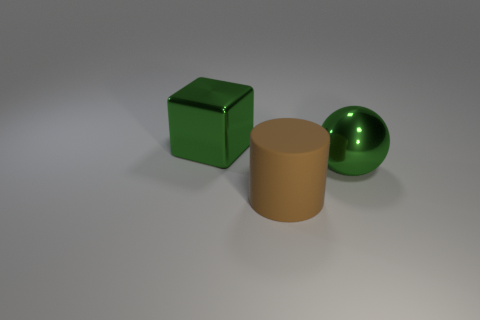There is a large metal sphere; how many shiny balls are to the left of it? In the image, there is a single large, shiny, green sphere on the right side with no other shiny balls to the left of it. The left of the sphere contains only a cube and a cylinder, which are not spherical. 